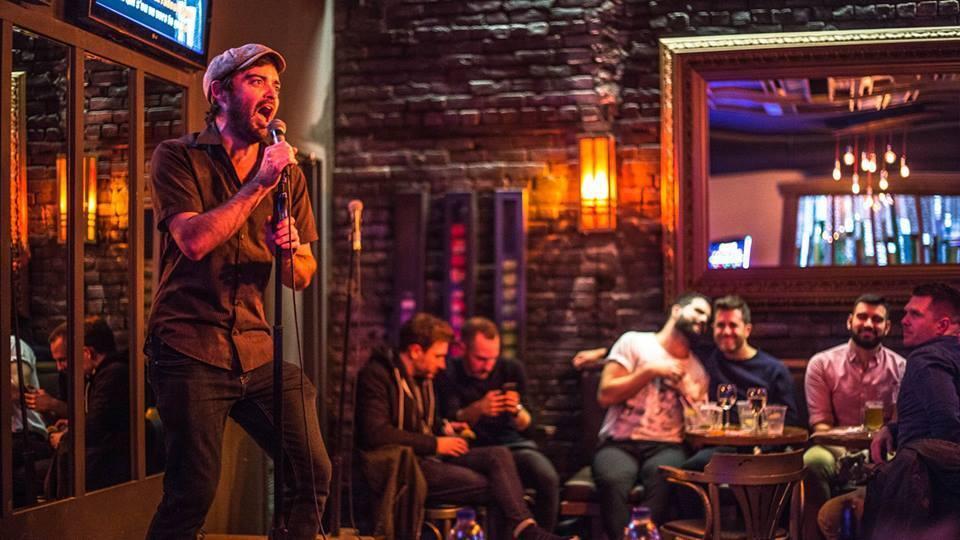What does the body language and interaction of the group of four men tell us about their relationship or the context of their conversation? The body language and interaction among the group of four men suggest they are in a relaxed and jovial setting, likely a social gathering in a bar. The close physical distance and gestures, such as one man's arm around another and expressions of laughter, reflect a comfortable and familiar relationship among friends. The presence of drinks and their attention towards an individual performing indicates they are enjoying a casual night out, engaging in light-hearted conversation possibly about the ongoing performance or sharing personal stories. 